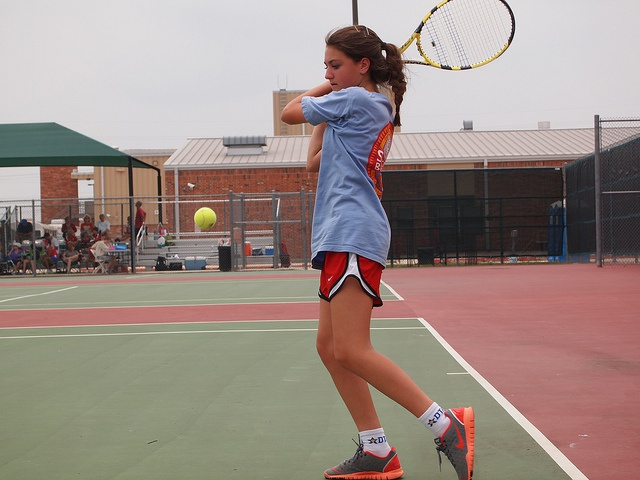Describe the objects in this image and their specific colors. I can see people in lightgray, gray, darkgray, and brown tones, tennis racket in lightgray, darkgray, black, and gray tones, bench in lightgray, gray, darkgray, and black tones, sports ball in lightgray, khaki, and olive tones, and people in lightgray, gray, darkgray, and maroon tones in this image. 